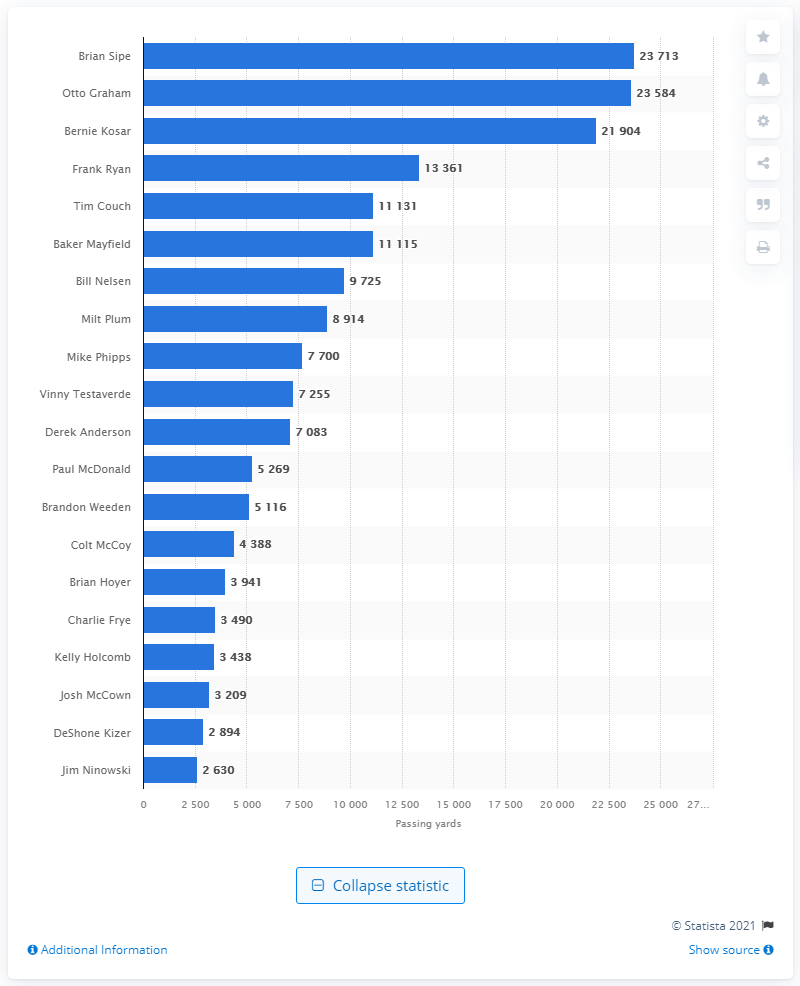Specify some key components in this picture. The Cleveland Browns' career passing leader is Brian Sipe. 